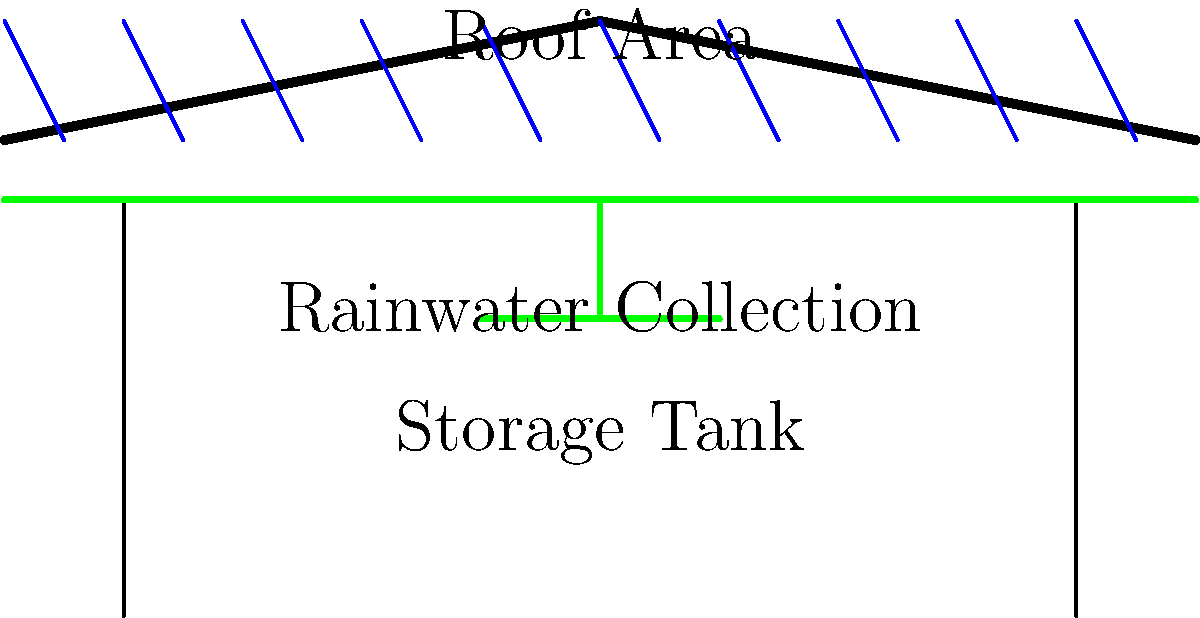You want to design a rainwater harvesting system for your sustainable home. Your roof has an area of 150 m² and the average annual rainfall in your region is 800 mm. Assuming 80% efficiency in collection, how many liters of water can you potentially harvest in a year? To calculate the potential rainwater harvest, we'll follow these steps:

1. Convert the rainfall from mm to m:
   800 mm = 0.8 m

2. Calculate the total volume of rainwater falling on the roof:
   Volume = Roof Area × Rainfall
   $V = 150 \text{ m}^2 \times 0.8 \text{ m} = 120 \text{ m}^3$

3. Convert cubic meters to liters:
   $1 \text{ m}^3 = 1000 \text{ L}$
   $120 \text{ m}^3 = 120,000 \text{ L}$

4. Apply the 80% efficiency:
   Harvestable water = Total volume × Efficiency
   $= 120,000 \text{ L} \times 0.80 = 96,000 \text{ L}$

Therefore, with 80% efficiency, you can potentially harvest 96,000 liters of rainwater in a year.
Answer: 96,000 liters 